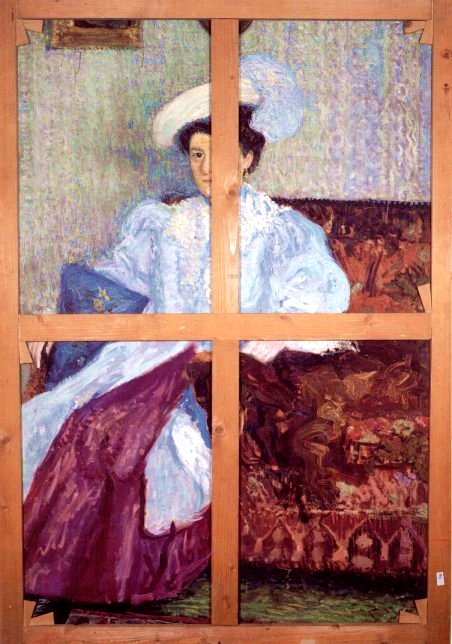What story could this painting be telling? This painting might be telling the story of a woman from the late 19th or early 20th century, dressed in elegant attire, sitting in a moment of deep reflection or reminiscence. The serene, thoughtful expression on her face suggests she may be thinking about a significant event or person in her life. The fragmented nature of the painting – with its division into four panels – could symbolize the multifaceted nature of her thoughts and memories. The vibrant colors and intricate details of her dress and surroundings hint at a setting steeped in sophistication and culture, possibly indicating her connection to a life of refinement and contemplation. Imagine this scene was taking place during a thunderstorm. How would that change the atmosphere of the painting? If this scene were taking place during a thunderstorm, the atmosphere of the painting would undergo a dramatic transformation. Dark, stormy clouds could cast deep shadows across the panels, altering the color palette to include cooler, darker tones. The serenity in the woman's expression might shift to one of concern or introspection brought on by the storm outside. The gentle brushstrokes might become more aggressive and chaotic, mimicking the turmoil of the storm. Raindrops could streak across the windows, and flashes of lightning could introduce sharp, bright highlights, adding an element of dynamic energy and tension to the previously calm scene. This setting would create a stark contrast, emphasizing the woman's solitude and contemplation amidst the chaos of the natural world. 